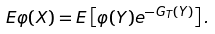<formula> <loc_0><loc_0><loc_500><loc_500>E \varphi ( X ) = E \left [ \varphi ( Y ) e ^ { - G _ { T } ( Y ) } \right ] .</formula> 